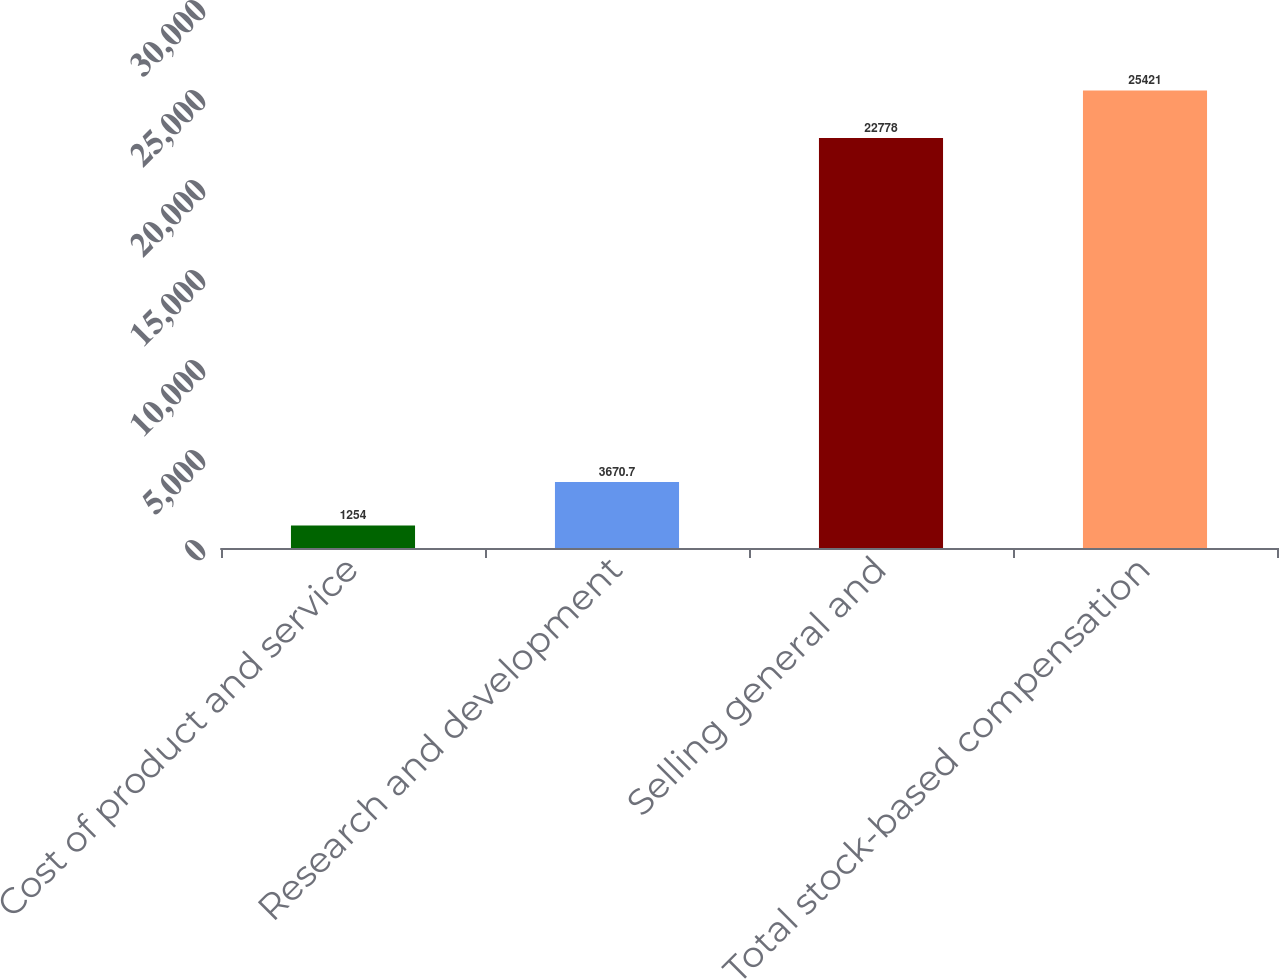<chart> <loc_0><loc_0><loc_500><loc_500><bar_chart><fcel>Cost of product and service<fcel>Research and development<fcel>Selling general and<fcel>Total stock-based compensation<nl><fcel>1254<fcel>3670.7<fcel>22778<fcel>25421<nl></chart> 